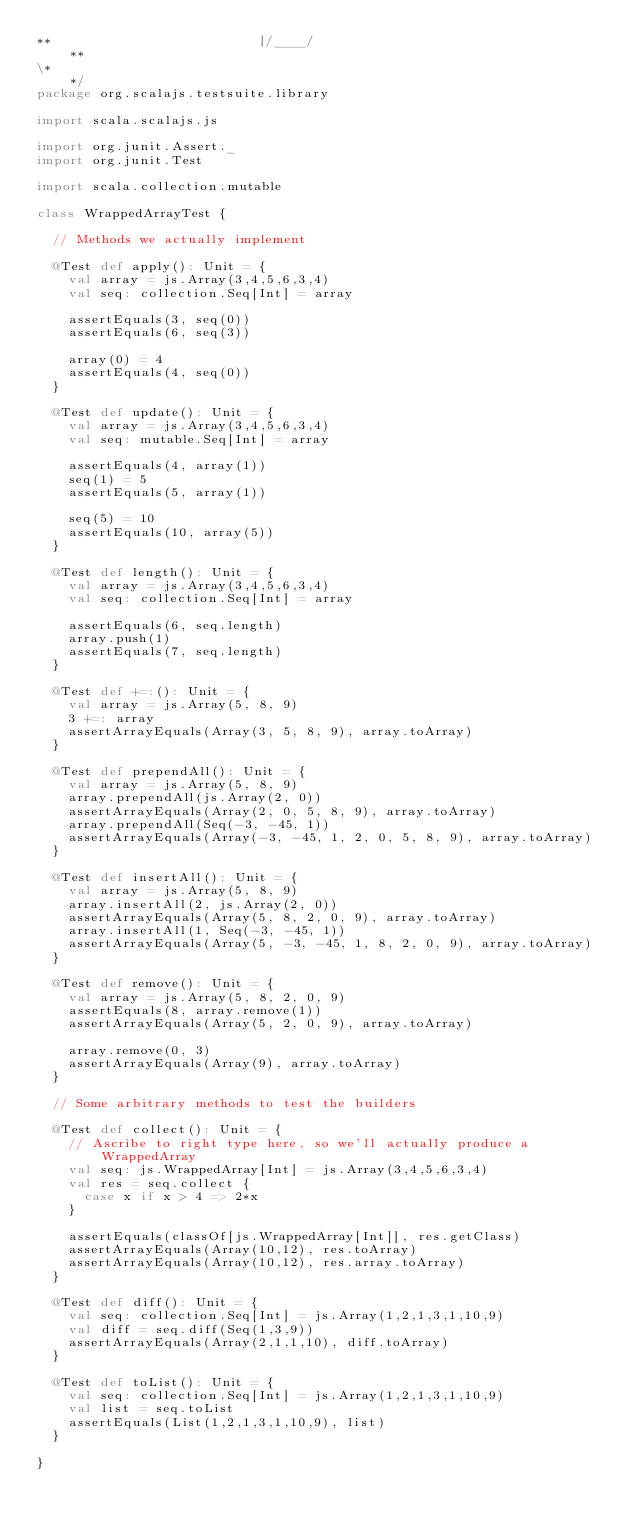<code> <loc_0><loc_0><loc_500><loc_500><_Scala_>**                          |/____/                                     **
\*                                                                      */
package org.scalajs.testsuite.library

import scala.scalajs.js

import org.junit.Assert._
import org.junit.Test

import scala.collection.mutable

class WrappedArrayTest {

  // Methods we actually implement

  @Test def apply(): Unit = {
    val array = js.Array(3,4,5,6,3,4)
    val seq: collection.Seq[Int] = array

    assertEquals(3, seq(0))
    assertEquals(6, seq(3))

    array(0) = 4
    assertEquals(4, seq(0))
  }

  @Test def update(): Unit = {
    val array = js.Array(3,4,5,6,3,4)
    val seq: mutable.Seq[Int] = array

    assertEquals(4, array(1))
    seq(1) = 5
    assertEquals(5, array(1))

    seq(5) = 10
    assertEquals(10, array(5))
  }

  @Test def length(): Unit = {
    val array = js.Array(3,4,5,6,3,4)
    val seq: collection.Seq[Int] = array

    assertEquals(6, seq.length)
    array.push(1)
    assertEquals(7, seq.length)
  }

  @Test def +=:(): Unit = {
    val array = js.Array(5, 8, 9)
    3 +=: array
    assertArrayEquals(Array(3, 5, 8, 9), array.toArray)
  }

  @Test def prependAll(): Unit = {
    val array = js.Array(5, 8, 9)
    array.prependAll(js.Array(2, 0))
    assertArrayEquals(Array(2, 0, 5, 8, 9), array.toArray)
    array.prependAll(Seq(-3, -45, 1))
    assertArrayEquals(Array(-3, -45, 1, 2, 0, 5, 8, 9), array.toArray)
  }

  @Test def insertAll(): Unit = {
    val array = js.Array(5, 8, 9)
    array.insertAll(2, js.Array(2, 0))
    assertArrayEquals(Array(5, 8, 2, 0, 9), array.toArray)
    array.insertAll(1, Seq(-3, -45, 1))
    assertArrayEquals(Array(5, -3, -45, 1, 8, 2, 0, 9), array.toArray)
  }

  @Test def remove(): Unit = {
    val array = js.Array(5, 8, 2, 0, 9)
    assertEquals(8, array.remove(1))
    assertArrayEquals(Array(5, 2, 0, 9), array.toArray)

    array.remove(0, 3)
    assertArrayEquals(Array(9), array.toArray)
  }

  // Some arbitrary methods to test the builders

  @Test def collect(): Unit = {
    // Ascribe to right type here, so we'll actually produce a WrappedArray
    val seq: js.WrappedArray[Int] = js.Array(3,4,5,6,3,4)
    val res = seq.collect {
      case x if x > 4 => 2*x
    }

    assertEquals(classOf[js.WrappedArray[Int]], res.getClass)
    assertArrayEquals(Array(10,12), res.toArray)
    assertArrayEquals(Array(10,12), res.array.toArray)
  }

  @Test def diff(): Unit = {
    val seq: collection.Seq[Int] = js.Array(1,2,1,3,1,10,9)
    val diff = seq.diff(Seq(1,3,9))
    assertArrayEquals(Array(2,1,1,10), diff.toArray)
  }

  @Test def toList(): Unit = {
    val seq: collection.Seq[Int] = js.Array(1,2,1,3,1,10,9)
    val list = seq.toList
    assertEquals(List(1,2,1,3,1,10,9), list)
  }

}
</code> 